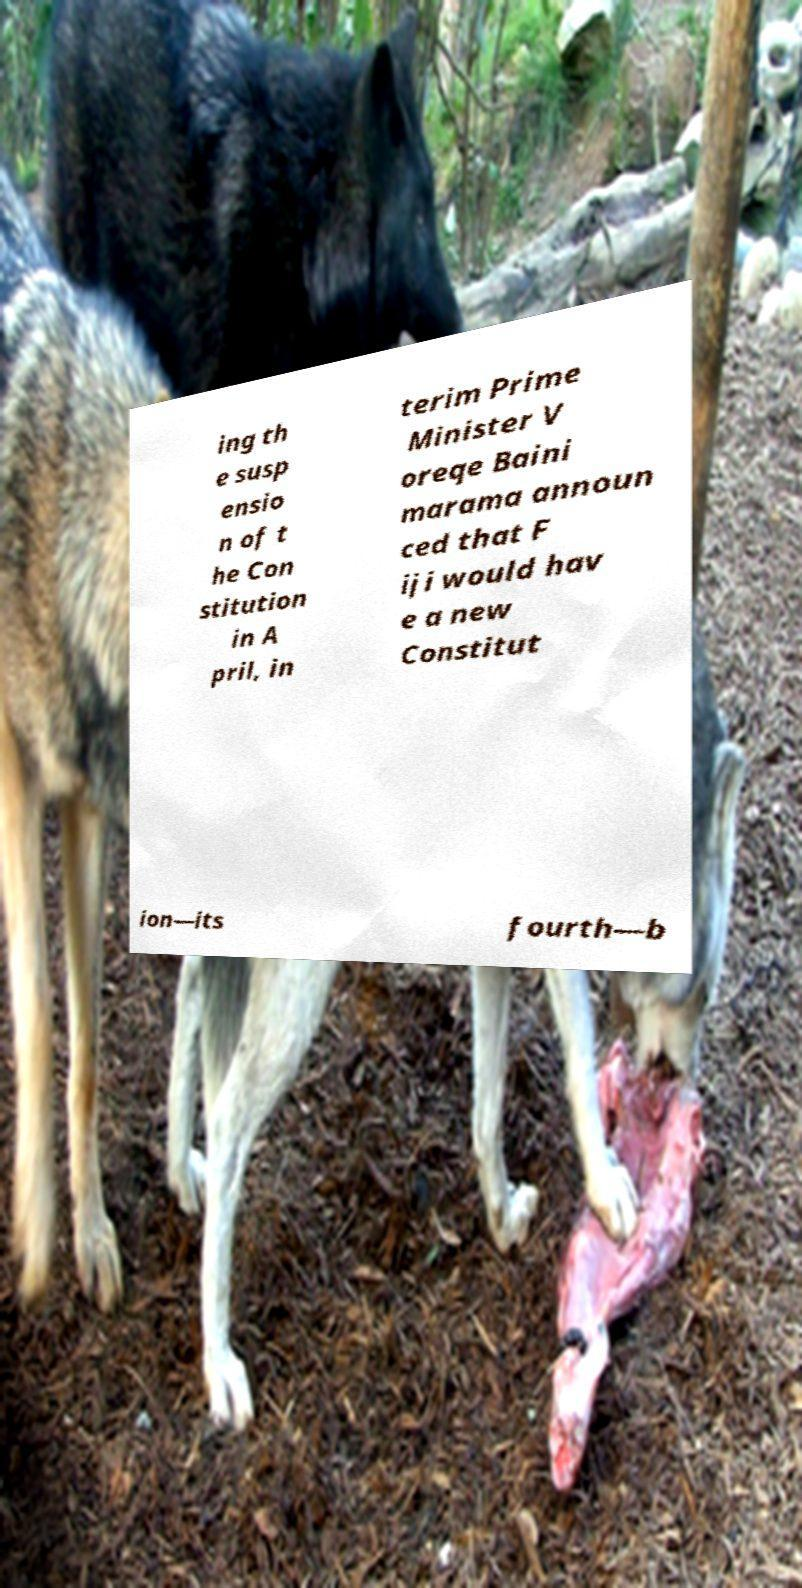Could you assist in decoding the text presented in this image and type it out clearly? ing th e susp ensio n of t he Con stitution in A pril, in terim Prime Minister V oreqe Baini marama announ ced that F iji would hav e a new Constitut ion—its fourth—b 